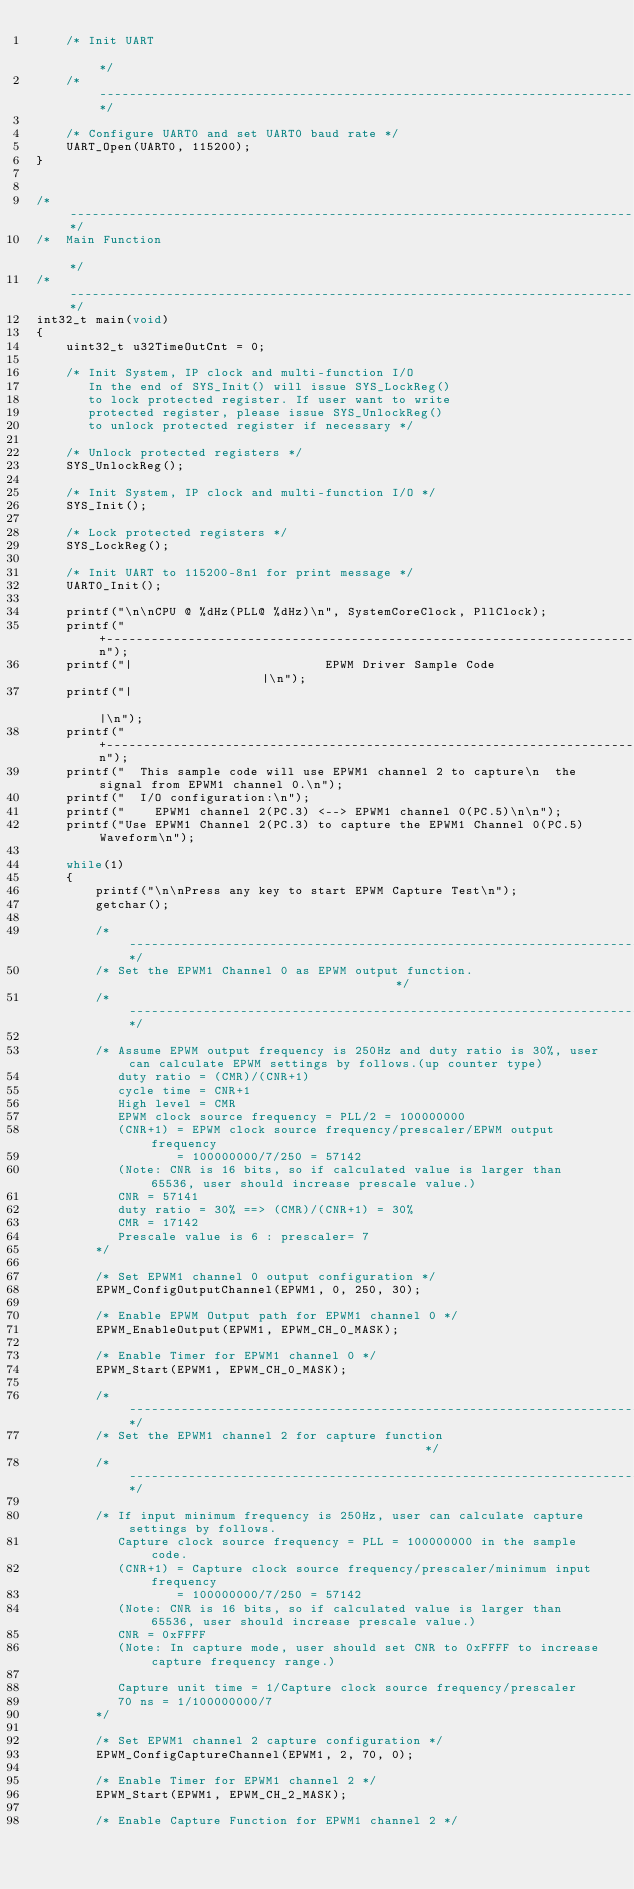<code> <loc_0><loc_0><loc_500><loc_500><_C_>    /* Init UART                                                                                               */
    /*---------------------------------------------------------------------------------------------------------*/

    /* Configure UART0 and set UART0 baud rate */
    UART_Open(UART0, 115200);
}


/*---------------------------------------------------------------------------------------------------------*/
/*  Main Function                                                                                          */
/*---------------------------------------------------------------------------------------------------------*/
int32_t main(void)
{
    uint32_t u32TimeOutCnt = 0;

    /* Init System, IP clock and multi-function I/O
       In the end of SYS_Init() will issue SYS_LockReg()
       to lock protected register. If user want to write
       protected register, please issue SYS_UnlockReg()
       to unlock protected register if necessary */

    /* Unlock protected registers */
    SYS_UnlockReg();

    /* Init System, IP clock and multi-function I/O */
    SYS_Init();

    /* Lock protected registers */
    SYS_LockReg();

    /* Init UART to 115200-8n1 for print message */
    UART0_Init();

    printf("\n\nCPU @ %dHz(PLL@ %dHz)\n", SystemCoreClock, PllClock);
    printf("+------------------------------------------------------------------------+\n");
    printf("|                          EPWM Driver Sample Code                       |\n");
    printf("|                                                                        |\n");
    printf("+------------------------------------------------------------------------+\n");
    printf("  This sample code will use EPWM1 channel 2 to capture\n  the signal from EPWM1 channel 0.\n");
    printf("  I/O configuration:\n");
    printf("    EPWM1 channel 2(PC.3) <--> EPWM1 channel 0(PC.5)\n\n");
    printf("Use EPWM1 Channel 2(PC.3) to capture the EPWM1 Channel 0(PC.5) Waveform\n");

    while(1)
    {
        printf("\n\nPress any key to start EPWM Capture Test\n");
        getchar();

        /*--------------------------------------------------------------------------------------*/
        /* Set the EPWM1 Channel 0 as EPWM output function.                                     */
        /*--------------------------------------------------------------------------------------*/

        /* Assume EPWM output frequency is 250Hz and duty ratio is 30%, user can calculate EPWM settings by follows.(up counter type)
           duty ratio = (CMR)/(CNR+1)
           cycle time = CNR+1
           High level = CMR
           EPWM clock source frequency = PLL/2 = 100000000
           (CNR+1) = EPWM clock source frequency/prescaler/EPWM output frequency
                   = 100000000/7/250 = 57142
           (Note: CNR is 16 bits, so if calculated value is larger than 65536, user should increase prescale value.)
           CNR = 57141
           duty ratio = 30% ==> (CMR)/(CNR+1) = 30%
           CMR = 17142
           Prescale value is 6 : prescaler= 7
        */

        /* Set EPWM1 channel 0 output configuration */
        EPWM_ConfigOutputChannel(EPWM1, 0, 250, 30);

        /* Enable EPWM Output path for EPWM1 channel 0 */
        EPWM_EnableOutput(EPWM1, EPWM_CH_0_MASK);

        /* Enable Timer for EPWM1 channel 0 */
        EPWM_Start(EPWM1, EPWM_CH_0_MASK);

        /*--------------------------------------------------------------------------------------*/
        /* Set the EPWM1 channel 2 for capture function                                         */
        /*--------------------------------------------------------------------------------------*/

        /* If input minimum frequency is 250Hz, user can calculate capture settings by follows.
           Capture clock source frequency = PLL = 100000000 in the sample code.
           (CNR+1) = Capture clock source frequency/prescaler/minimum input frequency
                   = 100000000/7/250 = 57142
           (Note: CNR is 16 bits, so if calculated value is larger than 65536, user should increase prescale value.)
           CNR = 0xFFFF
           (Note: In capture mode, user should set CNR to 0xFFFF to increase capture frequency range.)

           Capture unit time = 1/Capture clock source frequency/prescaler
           70 ns = 1/100000000/7
        */

        /* Set EPWM1 channel 2 capture configuration */
        EPWM_ConfigCaptureChannel(EPWM1, 2, 70, 0);

        /* Enable Timer for EPWM1 channel 2 */
        EPWM_Start(EPWM1, EPWM_CH_2_MASK);

        /* Enable Capture Function for EPWM1 channel 2 */</code> 